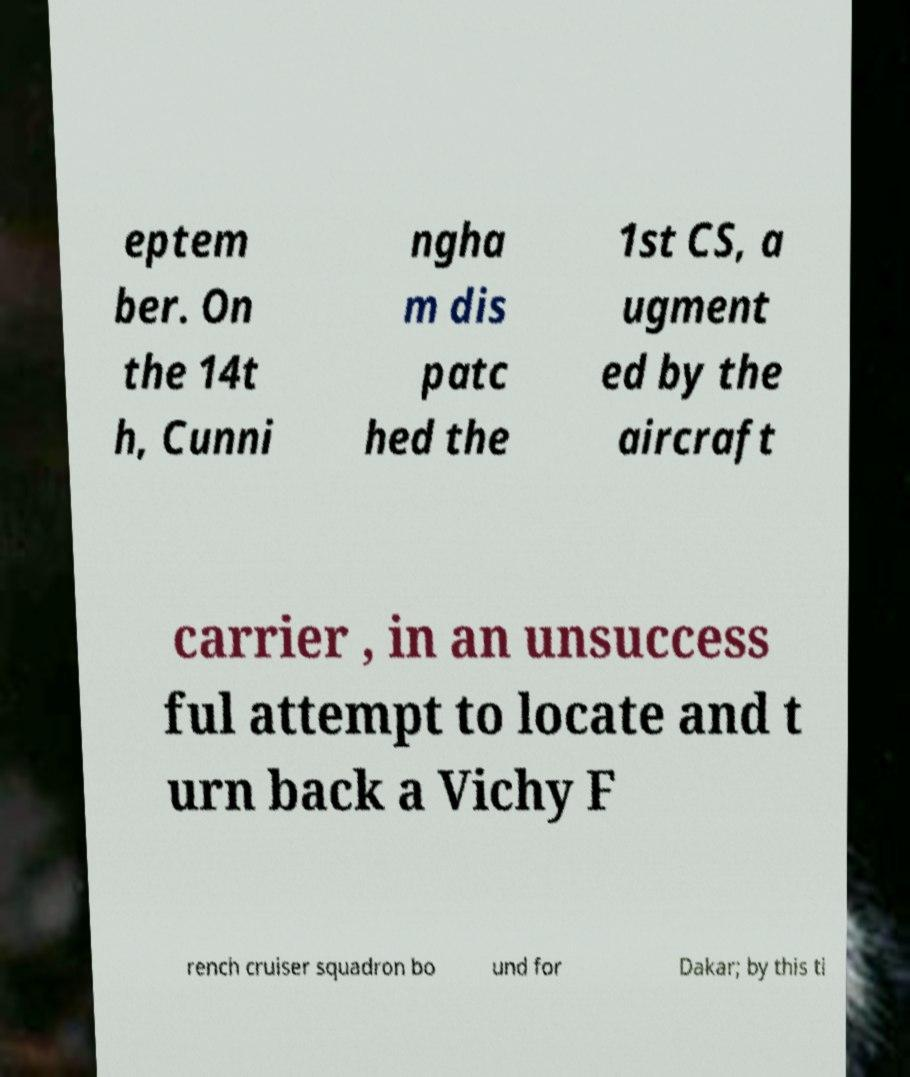For documentation purposes, I need the text within this image transcribed. Could you provide that? eptem ber. On the 14t h, Cunni ngha m dis patc hed the 1st CS, a ugment ed by the aircraft carrier , in an unsuccess ful attempt to locate and t urn back a Vichy F rench cruiser squadron bo und for Dakar; by this ti 